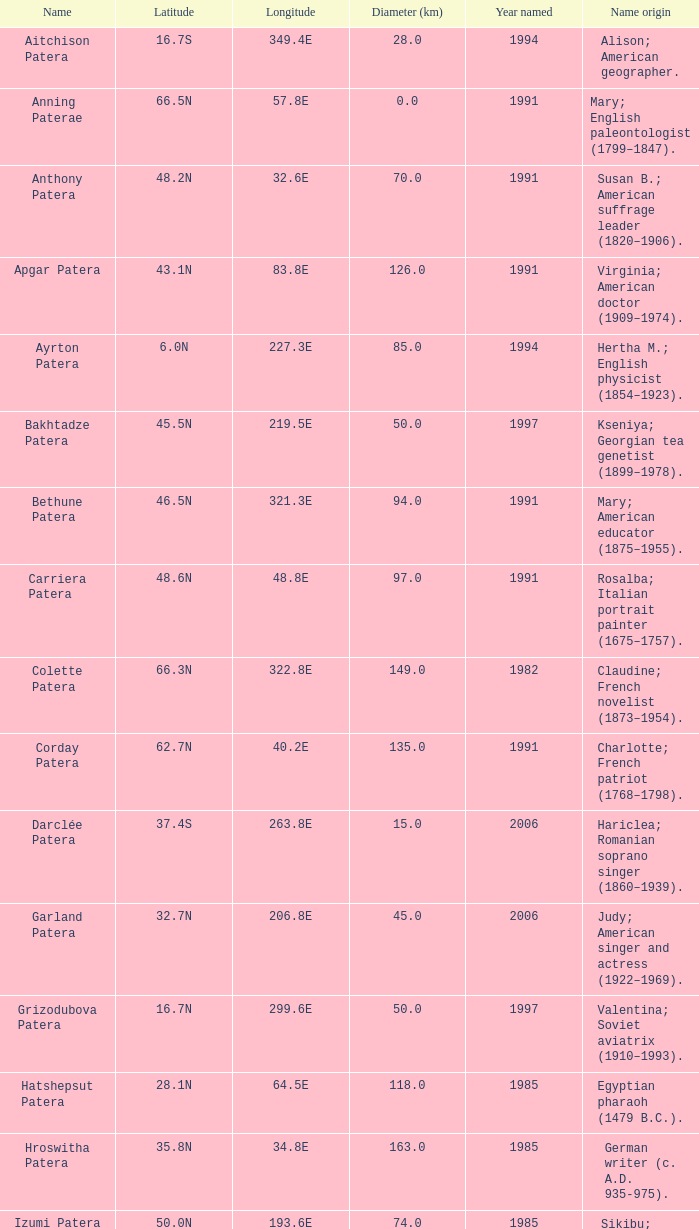3s latitude christened? 2000.0. 